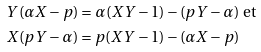Convert formula to latex. <formula><loc_0><loc_0><loc_500><loc_500>Y ( \alpha X - p ) & = \alpha ( X Y - 1 ) - ( p Y - \alpha ) \ \text {et} \\ X ( p Y - \alpha ) & = p ( X Y - 1 ) - ( \alpha X - p )</formula> 